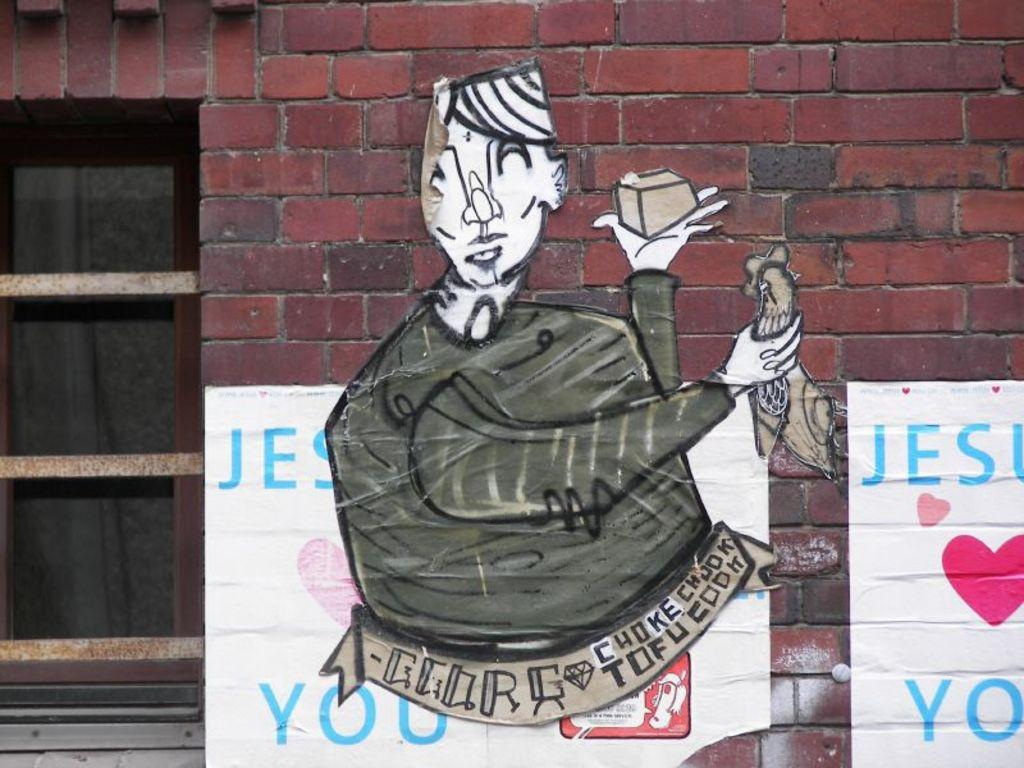What type of structure is visible in the image? There is a brick wall in the image. What is attached to the brick wall? There are posters on the brick wall. Can you describe another feature in the image? There is a glass window in the image. How many pigs can be seen crawling on the glass window in the image? There are no pigs present in the image, and therefore no pigs can be seen crawling on the glass window. 